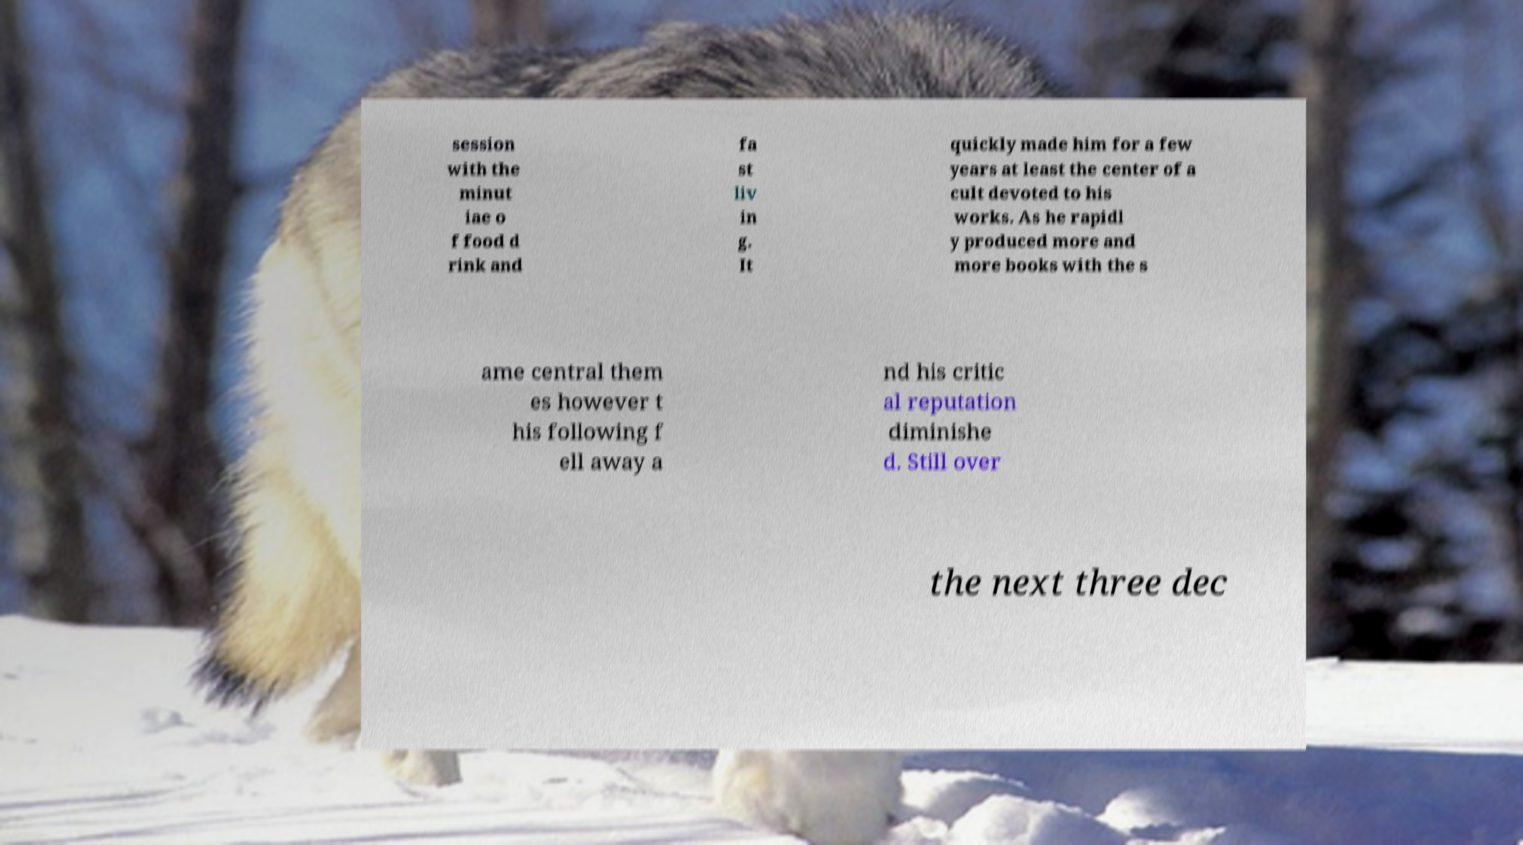Please identify and transcribe the text found in this image. session with the minut iae o f food d rink and fa st liv in g. It quickly made him for a few years at least the center of a cult devoted to his works. As he rapidl y produced more and more books with the s ame central them es however t his following f ell away a nd his critic al reputation diminishe d. Still over the next three dec 